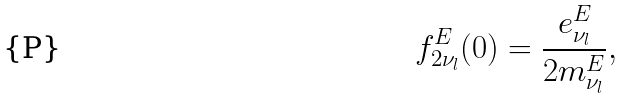Convert formula to latex. <formula><loc_0><loc_0><loc_500><loc_500>f _ { 2 \nu _ { l } } ^ { E } ( 0 ) = \frac { e _ { \nu _ { l } } ^ { E } } { 2 m _ { \nu _ { l } } ^ { E } } ,</formula> 